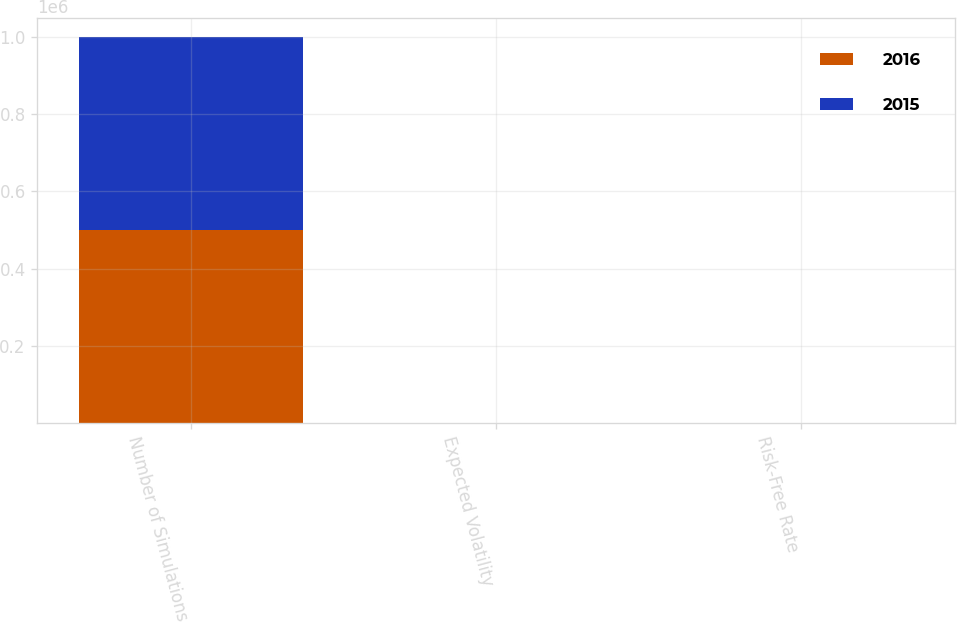<chart> <loc_0><loc_0><loc_500><loc_500><stacked_bar_chart><ecel><fcel>Number of Simulations<fcel>Expected Volatility<fcel>Risk-Free Rate<nl><fcel>2016<fcel>500000<fcel>38<fcel>1<nl><fcel>2015<fcel>500000<fcel>30<fcel>0.8<nl></chart> 